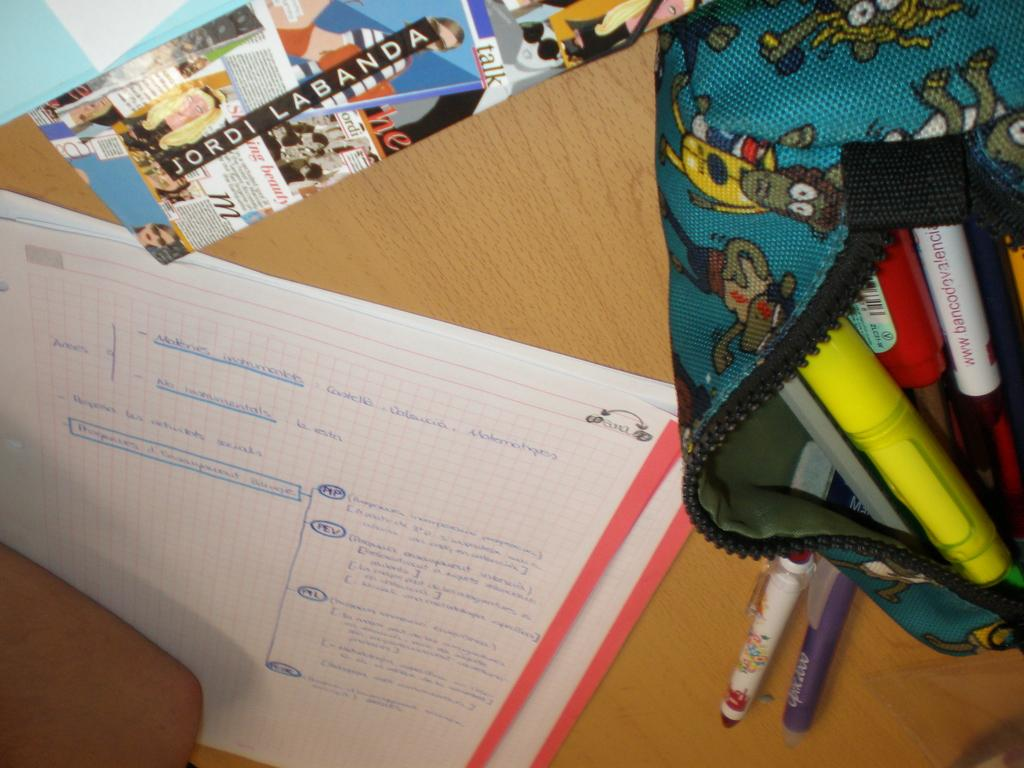<image>
Offer a succinct explanation of the picture presented. A desk with several papers on including a pamphlet labels Jordi Labanda 